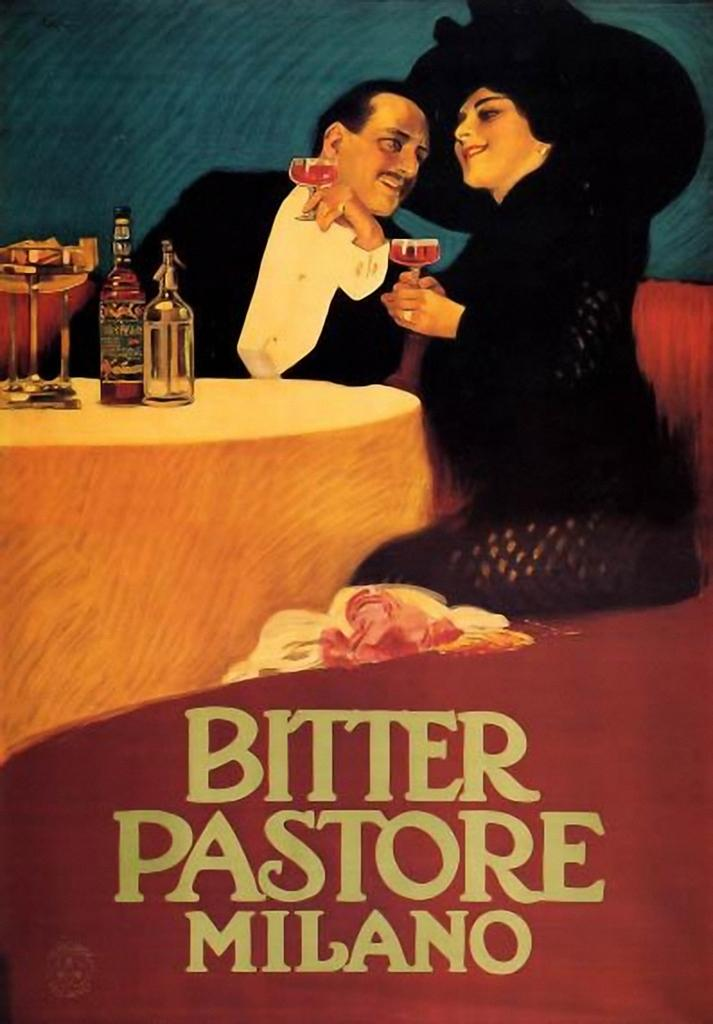Who is present in the image? There is a woman and a man in the image. What are they doing in the image? Both the woman and the man are sitting on chairs. What are they holding in their hands? They are holding glasses in their hands. Where are they located in the image? They are at a table. What type of pen does the woman use to express her beliefs in the image? There is no pen or expression of beliefs present in the image. 